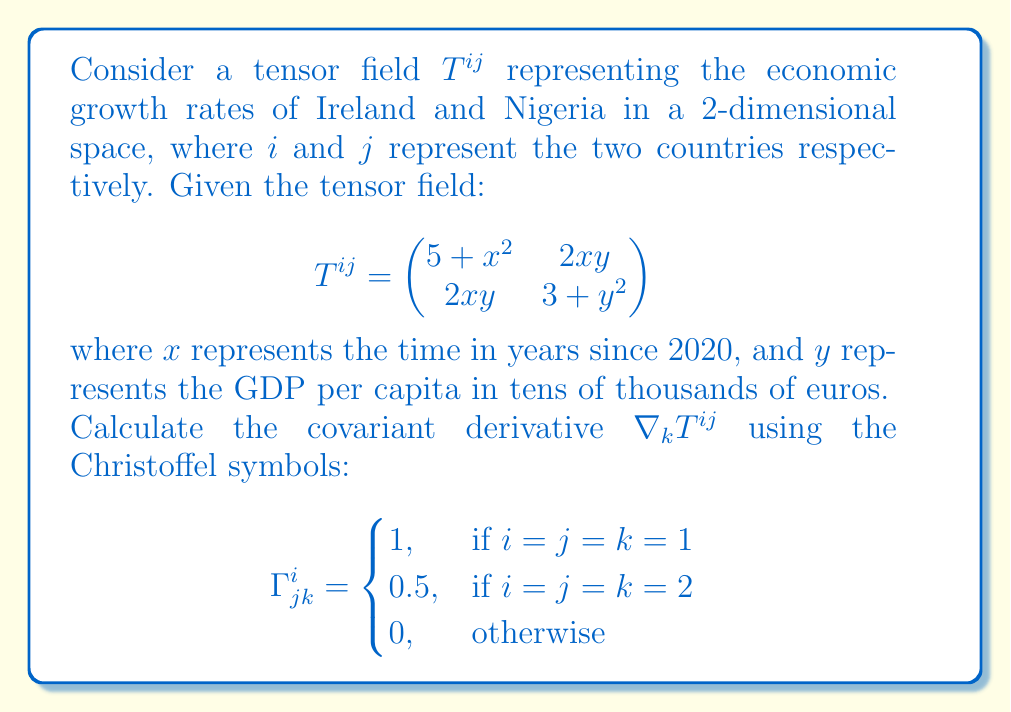Help me with this question. To find the covariant derivative of the tensor field, we'll use the formula:

$$\nabla_k T^{ij} = \partial_k T^{ij} + \Gamma^i_{lk} T^{lj} + \Gamma^j_{lk} T^{il}$$

Step 1: Calculate $\partial_k T^{ij}$ for each component:
- $\partial_1 T^{11} = 2x$
- $\partial_1 T^{12} = \partial_1 T^{21} = 2y$
- $\partial_1 T^{22} = 0$
- $\partial_2 T^{11} = 0$
- $\partial_2 T^{12} = \partial_2 T^{21} = 2x$
- $\partial_2 T^{22} = 2y$

Step 2: Calculate $\Gamma^i_{lk} T^{lj}$ and $\Gamma^j_{lk} T^{il}$ for each component:

For $k=1$:
- $\Gamma^1_{11} T^{11} = 1 \cdot (5+x^2) = 5+x^2$
- $\Gamma^1_{11} T^{21} = 1 \cdot 2xy = 2xy$
- All other terms are zero

For $k=2$:
- $\Gamma^2_{22} T^{12} = 0.5 \cdot 2xy = xy$
- $\Gamma^2_{22} T^{22} = 0.5 \cdot (3+y^2) = 1.5 + 0.5y^2$
- All other terms are zero

Step 3: Sum up the terms for each component of $\nabla_k T^{ij}$:

$\nabla_1 T^{11} = 2x + (5+x^2) = 7 + x^2$
$\nabla_1 T^{12} = 2y$
$\nabla_1 T^{21} = 2y + 2xy = 2y(1+x)$
$\nabla_1 T^{22} = 0$

$\nabla_2 T^{11} = 0$
$\nabla_2 T^{12} = 2x + xy = x(2+y)$
$\nabla_2 T^{21} = 2x$
$\nabla_2 T^{22} = 2y + (1.5 + 0.5y^2) = 1.5 + 2y + 0.5y^2$

Therefore, the covariant derivative $\nabla_k T^{ij}$ is:

$$\nabla_k T^{ij} = \begin{pmatrix}
7 + x^2 & 2y & 0 & x(2+y) \\
2y(1+x) & 0 & 2x & 1.5 + 2y + 0.5y^2
\end{pmatrix}$$

where the rows represent $k=1$ and $k=2$, and the columns represent the components $(i,j) = (1,1), (1,2), (2,1), (2,2)$.
Answer: $$\nabla_k T^{ij} = \begin{pmatrix}
7 + x^2 & 2y & 0 & x(2+y) \\
2y(1+x) & 0 & 2x & 1.5 + 2y + 0.5y^2
\end{pmatrix}$$ 